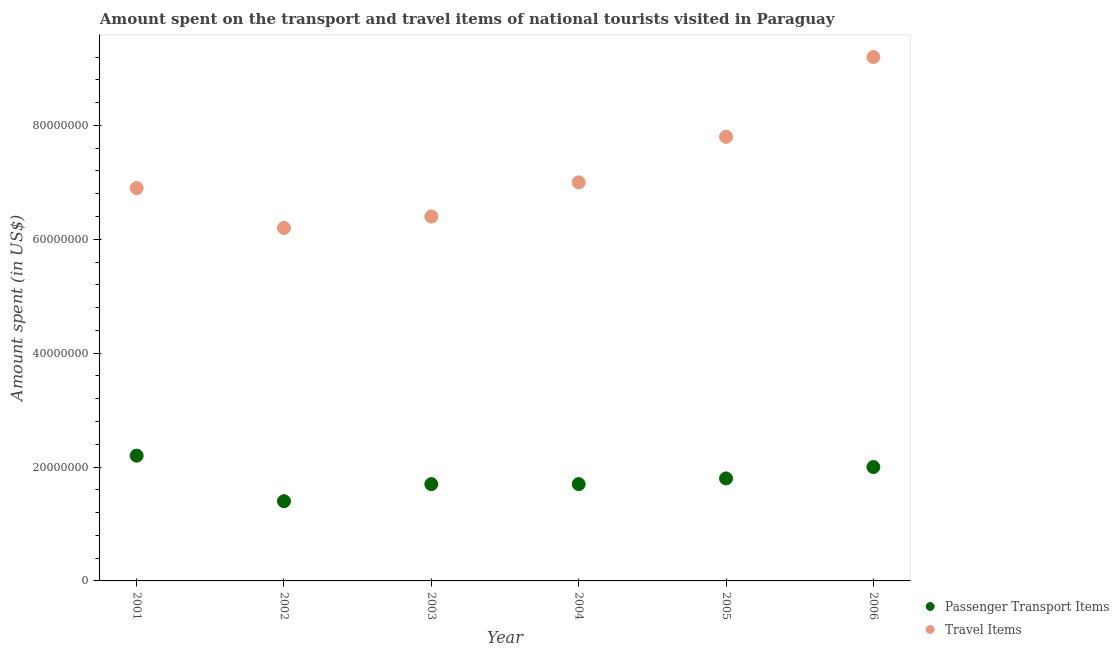What is the amount spent in travel items in 2006?
Make the answer very short. 9.20e+07. Across all years, what is the maximum amount spent on passenger transport items?
Offer a very short reply. 2.20e+07. Across all years, what is the minimum amount spent on passenger transport items?
Your response must be concise. 1.40e+07. What is the total amount spent on passenger transport items in the graph?
Offer a terse response. 1.08e+08. What is the difference between the amount spent on passenger transport items in 2005 and that in 2006?
Provide a succinct answer. -2.00e+06. What is the difference between the amount spent in travel items in 2001 and the amount spent on passenger transport items in 2004?
Provide a short and direct response. 5.20e+07. What is the average amount spent in travel items per year?
Your answer should be compact. 7.25e+07. In the year 2002, what is the difference between the amount spent on passenger transport items and amount spent in travel items?
Give a very brief answer. -4.80e+07. What is the ratio of the amount spent on passenger transport items in 2003 to that in 2004?
Ensure brevity in your answer.  1. Is the difference between the amount spent on passenger transport items in 2003 and 2004 greater than the difference between the amount spent in travel items in 2003 and 2004?
Keep it short and to the point. Yes. What is the difference between the highest and the second highest amount spent in travel items?
Your answer should be compact. 1.40e+07. What is the difference between the highest and the lowest amount spent in travel items?
Your answer should be very brief. 3.00e+07. Is the sum of the amount spent on passenger transport items in 2001 and 2003 greater than the maximum amount spent in travel items across all years?
Make the answer very short. No. Does the amount spent in travel items monotonically increase over the years?
Make the answer very short. No. Is the amount spent in travel items strictly less than the amount spent on passenger transport items over the years?
Offer a very short reply. No. How many dotlines are there?
Keep it short and to the point. 2. What is the difference between two consecutive major ticks on the Y-axis?
Make the answer very short. 2.00e+07. Does the graph contain any zero values?
Make the answer very short. No. Where does the legend appear in the graph?
Give a very brief answer. Bottom right. How are the legend labels stacked?
Provide a succinct answer. Vertical. What is the title of the graph?
Keep it short and to the point. Amount spent on the transport and travel items of national tourists visited in Paraguay. What is the label or title of the X-axis?
Offer a very short reply. Year. What is the label or title of the Y-axis?
Provide a succinct answer. Amount spent (in US$). What is the Amount spent (in US$) of Passenger Transport Items in 2001?
Give a very brief answer. 2.20e+07. What is the Amount spent (in US$) of Travel Items in 2001?
Offer a terse response. 6.90e+07. What is the Amount spent (in US$) of Passenger Transport Items in 2002?
Give a very brief answer. 1.40e+07. What is the Amount spent (in US$) in Travel Items in 2002?
Your answer should be very brief. 6.20e+07. What is the Amount spent (in US$) of Passenger Transport Items in 2003?
Ensure brevity in your answer.  1.70e+07. What is the Amount spent (in US$) of Travel Items in 2003?
Make the answer very short. 6.40e+07. What is the Amount spent (in US$) of Passenger Transport Items in 2004?
Your answer should be compact. 1.70e+07. What is the Amount spent (in US$) in Travel Items in 2004?
Make the answer very short. 7.00e+07. What is the Amount spent (in US$) of Passenger Transport Items in 2005?
Your answer should be very brief. 1.80e+07. What is the Amount spent (in US$) in Travel Items in 2005?
Provide a short and direct response. 7.80e+07. What is the Amount spent (in US$) of Passenger Transport Items in 2006?
Ensure brevity in your answer.  2.00e+07. What is the Amount spent (in US$) of Travel Items in 2006?
Your response must be concise. 9.20e+07. Across all years, what is the maximum Amount spent (in US$) of Passenger Transport Items?
Your answer should be compact. 2.20e+07. Across all years, what is the maximum Amount spent (in US$) in Travel Items?
Your answer should be very brief. 9.20e+07. Across all years, what is the minimum Amount spent (in US$) in Passenger Transport Items?
Make the answer very short. 1.40e+07. Across all years, what is the minimum Amount spent (in US$) of Travel Items?
Provide a short and direct response. 6.20e+07. What is the total Amount spent (in US$) in Passenger Transport Items in the graph?
Offer a very short reply. 1.08e+08. What is the total Amount spent (in US$) in Travel Items in the graph?
Keep it short and to the point. 4.35e+08. What is the difference between the Amount spent (in US$) in Travel Items in 2001 and that in 2002?
Provide a short and direct response. 7.00e+06. What is the difference between the Amount spent (in US$) in Travel Items in 2001 and that in 2003?
Your answer should be very brief. 5.00e+06. What is the difference between the Amount spent (in US$) in Travel Items in 2001 and that in 2004?
Ensure brevity in your answer.  -1.00e+06. What is the difference between the Amount spent (in US$) in Travel Items in 2001 and that in 2005?
Offer a terse response. -9.00e+06. What is the difference between the Amount spent (in US$) of Travel Items in 2001 and that in 2006?
Your answer should be compact. -2.30e+07. What is the difference between the Amount spent (in US$) of Passenger Transport Items in 2002 and that in 2003?
Your answer should be compact. -3.00e+06. What is the difference between the Amount spent (in US$) of Passenger Transport Items in 2002 and that in 2004?
Ensure brevity in your answer.  -3.00e+06. What is the difference between the Amount spent (in US$) in Travel Items in 2002 and that in 2004?
Offer a very short reply. -8.00e+06. What is the difference between the Amount spent (in US$) in Passenger Transport Items in 2002 and that in 2005?
Ensure brevity in your answer.  -4.00e+06. What is the difference between the Amount spent (in US$) of Travel Items in 2002 and that in 2005?
Offer a terse response. -1.60e+07. What is the difference between the Amount spent (in US$) of Passenger Transport Items in 2002 and that in 2006?
Offer a terse response. -6.00e+06. What is the difference between the Amount spent (in US$) in Travel Items in 2002 and that in 2006?
Make the answer very short. -3.00e+07. What is the difference between the Amount spent (in US$) in Travel Items in 2003 and that in 2004?
Give a very brief answer. -6.00e+06. What is the difference between the Amount spent (in US$) in Passenger Transport Items in 2003 and that in 2005?
Provide a succinct answer. -1.00e+06. What is the difference between the Amount spent (in US$) in Travel Items in 2003 and that in 2005?
Offer a very short reply. -1.40e+07. What is the difference between the Amount spent (in US$) of Passenger Transport Items in 2003 and that in 2006?
Make the answer very short. -3.00e+06. What is the difference between the Amount spent (in US$) in Travel Items in 2003 and that in 2006?
Provide a succinct answer. -2.80e+07. What is the difference between the Amount spent (in US$) in Travel Items in 2004 and that in 2005?
Your answer should be very brief. -8.00e+06. What is the difference between the Amount spent (in US$) in Travel Items in 2004 and that in 2006?
Offer a terse response. -2.20e+07. What is the difference between the Amount spent (in US$) in Travel Items in 2005 and that in 2006?
Give a very brief answer. -1.40e+07. What is the difference between the Amount spent (in US$) in Passenger Transport Items in 2001 and the Amount spent (in US$) in Travel Items in 2002?
Your answer should be very brief. -4.00e+07. What is the difference between the Amount spent (in US$) of Passenger Transport Items in 2001 and the Amount spent (in US$) of Travel Items in 2003?
Offer a very short reply. -4.20e+07. What is the difference between the Amount spent (in US$) of Passenger Transport Items in 2001 and the Amount spent (in US$) of Travel Items in 2004?
Make the answer very short. -4.80e+07. What is the difference between the Amount spent (in US$) in Passenger Transport Items in 2001 and the Amount spent (in US$) in Travel Items in 2005?
Your answer should be very brief. -5.60e+07. What is the difference between the Amount spent (in US$) of Passenger Transport Items in 2001 and the Amount spent (in US$) of Travel Items in 2006?
Provide a succinct answer. -7.00e+07. What is the difference between the Amount spent (in US$) of Passenger Transport Items in 2002 and the Amount spent (in US$) of Travel Items in 2003?
Give a very brief answer. -5.00e+07. What is the difference between the Amount spent (in US$) in Passenger Transport Items in 2002 and the Amount spent (in US$) in Travel Items in 2004?
Make the answer very short. -5.60e+07. What is the difference between the Amount spent (in US$) in Passenger Transport Items in 2002 and the Amount spent (in US$) in Travel Items in 2005?
Give a very brief answer. -6.40e+07. What is the difference between the Amount spent (in US$) in Passenger Transport Items in 2002 and the Amount spent (in US$) in Travel Items in 2006?
Offer a terse response. -7.80e+07. What is the difference between the Amount spent (in US$) of Passenger Transport Items in 2003 and the Amount spent (in US$) of Travel Items in 2004?
Your response must be concise. -5.30e+07. What is the difference between the Amount spent (in US$) of Passenger Transport Items in 2003 and the Amount spent (in US$) of Travel Items in 2005?
Your answer should be very brief. -6.10e+07. What is the difference between the Amount spent (in US$) in Passenger Transport Items in 2003 and the Amount spent (in US$) in Travel Items in 2006?
Make the answer very short. -7.50e+07. What is the difference between the Amount spent (in US$) in Passenger Transport Items in 2004 and the Amount spent (in US$) in Travel Items in 2005?
Your response must be concise. -6.10e+07. What is the difference between the Amount spent (in US$) in Passenger Transport Items in 2004 and the Amount spent (in US$) in Travel Items in 2006?
Ensure brevity in your answer.  -7.50e+07. What is the difference between the Amount spent (in US$) of Passenger Transport Items in 2005 and the Amount spent (in US$) of Travel Items in 2006?
Give a very brief answer. -7.40e+07. What is the average Amount spent (in US$) of Passenger Transport Items per year?
Ensure brevity in your answer.  1.80e+07. What is the average Amount spent (in US$) in Travel Items per year?
Provide a short and direct response. 7.25e+07. In the year 2001, what is the difference between the Amount spent (in US$) of Passenger Transport Items and Amount spent (in US$) of Travel Items?
Ensure brevity in your answer.  -4.70e+07. In the year 2002, what is the difference between the Amount spent (in US$) in Passenger Transport Items and Amount spent (in US$) in Travel Items?
Keep it short and to the point. -4.80e+07. In the year 2003, what is the difference between the Amount spent (in US$) in Passenger Transport Items and Amount spent (in US$) in Travel Items?
Ensure brevity in your answer.  -4.70e+07. In the year 2004, what is the difference between the Amount spent (in US$) in Passenger Transport Items and Amount spent (in US$) in Travel Items?
Your answer should be compact. -5.30e+07. In the year 2005, what is the difference between the Amount spent (in US$) in Passenger Transport Items and Amount spent (in US$) in Travel Items?
Offer a terse response. -6.00e+07. In the year 2006, what is the difference between the Amount spent (in US$) of Passenger Transport Items and Amount spent (in US$) of Travel Items?
Ensure brevity in your answer.  -7.20e+07. What is the ratio of the Amount spent (in US$) in Passenger Transport Items in 2001 to that in 2002?
Ensure brevity in your answer.  1.57. What is the ratio of the Amount spent (in US$) in Travel Items in 2001 to that in 2002?
Provide a short and direct response. 1.11. What is the ratio of the Amount spent (in US$) of Passenger Transport Items in 2001 to that in 2003?
Provide a succinct answer. 1.29. What is the ratio of the Amount spent (in US$) in Travel Items in 2001 to that in 2003?
Make the answer very short. 1.08. What is the ratio of the Amount spent (in US$) of Passenger Transport Items in 2001 to that in 2004?
Offer a very short reply. 1.29. What is the ratio of the Amount spent (in US$) of Travel Items in 2001 to that in 2004?
Provide a short and direct response. 0.99. What is the ratio of the Amount spent (in US$) of Passenger Transport Items in 2001 to that in 2005?
Offer a very short reply. 1.22. What is the ratio of the Amount spent (in US$) of Travel Items in 2001 to that in 2005?
Make the answer very short. 0.88. What is the ratio of the Amount spent (in US$) in Travel Items in 2001 to that in 2006?
Provide a short and direct response. 0.75. What is the ratio of the Amount spent (in US$) of Passenger Transport Items in 2002 to that in 2003?
Your answer should be very brief. 0.82. What is the ratio of the Amount spent (in US$) in Travel Items in 2002 to that in 2003?
Your response must be concise. 0.97. What is the ratio of the Amount spent (in US$) in Passenger Transport Items in 2002 to that in 2004?
Offer a very short reply. 0.82. What is the ratio of the Amount spent (in US$) in Travel Items in 2002 to that in 2004?
Keep it short and to the point. 0.89. What is the ratio of the Amount spent (in US$) of Travel Items in 2002 to that in 2005?
Make the answer very short. 0.79. What is the ratio of the Amount spent (in US$) of Travel Items in 2002 to that in 2006?
Offer a very short reply. 0.67. What is the ratio of the Amount spent (in US$) of Travel Items in 2003 to that in 2004?
Provide a short and direct response. 0.91. What is the ratio of the Amount spent (in US$) in Passenger Transport Items in 2003 to that in 2005?
Your answer should be very brief. 0.94. What is the ratio of the Amount spent (in US$) in Travel Items in 2003 to that in 2005?
Your answer should be very brief. 0.82. What is the ratio of the Amount spent (in US$) of Travel Items in 2003 to that in 2006?
Offer a terse response. 0.7. What is the ratio of the Amount spent (in US$) in Travel Items in 2004 to that in 2005?
Make the answer very short. 0.9. What is the ratio of the Amount spent (in US$) in Travel Items in 2004 to that in 2006?
Make the answer very short. 0.76. What is the ratio of the Amount spent (in US$) in Passenger Transport Items in 2005 to that in 2006?
Provide a short and direct response. 0.9. What is the ratio of the Amount spent (in US$) of Travel Items in 2005 to that in 2006?
Ensure brevity in your answer.  0.85. What is the difference between the highest and the second highest Amount spent (in US$) in Passenger Transport Items?
Your answer should be compact. 2.00e+06. What is the difference between the highest and the second highest Amount spent (in US$) of Travel Items?
Keep it short and to the point. 1.40e+07. What is the difference between the highest and the lowest Amount spent (in US$) in Travel Items?
Offer a very short reply. 3.00e+07. 